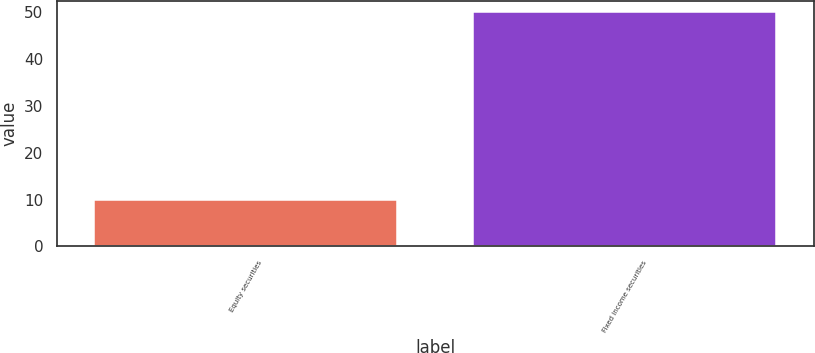Convert chart to OTSL. <chart><loc_0><loc_0><loc_500><loc_500><bar_chart><fcel>Equity securities<fcel>Fixed income securities<nl><fcel>10<fcel>50<nl></chart> 